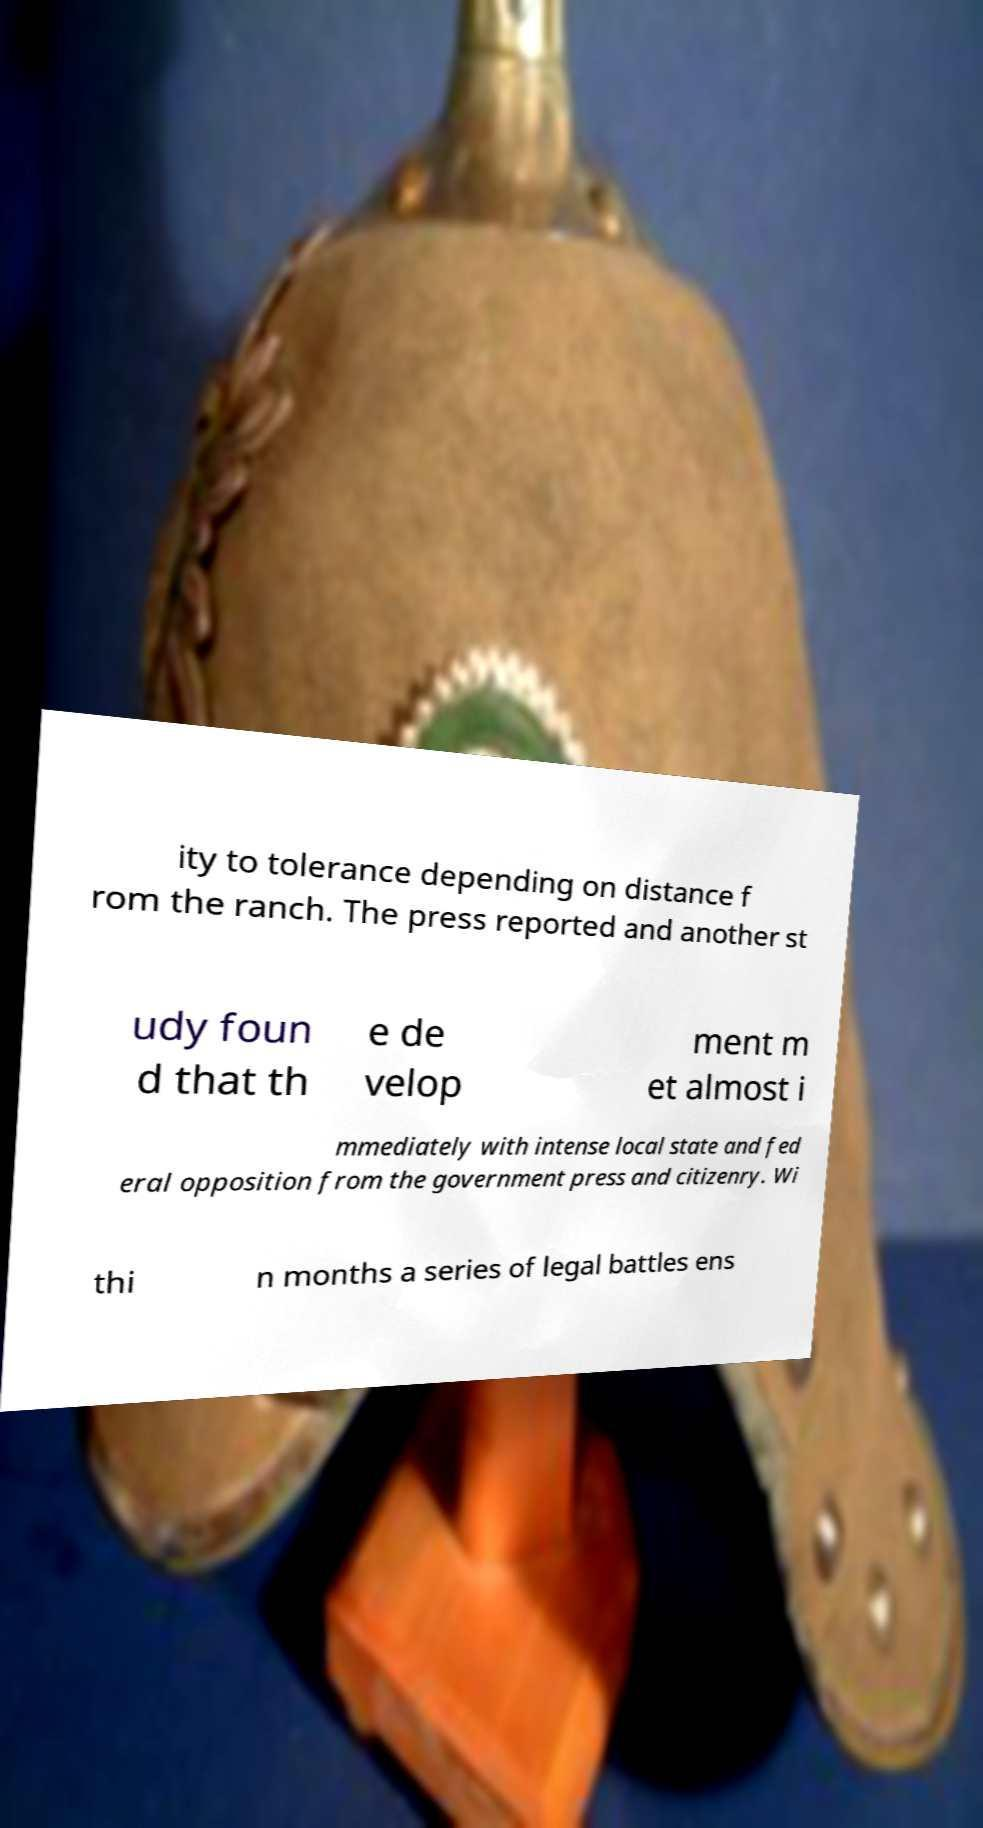For documentation purposes, I need the text within this image transcribed. Could you provide that? ity to tolerance depending on distance f rom the ranch. The press reported and another st udy foun d that th e de velop ment m et almost i mmediately with intense local state and fed eral opposition from the government press and citizenry. Wi thi n months a series of legal battles ens 